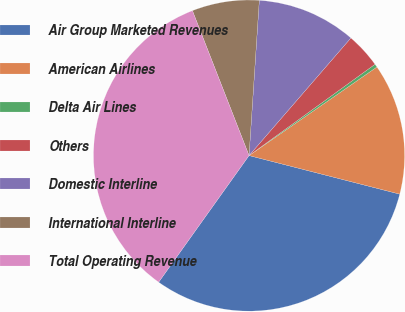Convert chart. <chart><loc_0><loc_0><loc_500><loc_500><pie_chart><fcel>Air Group Marketed Revenues<fcel>American Airlines<fcel>Delta Air Lines<fcel>Others<fcel>Domestic Interline<fcel>International Interline<fcel>Total Operating Revenue<nl><fcel>30.88%<fcel>13.63%<fcel>0.34%<fcel>3.66%<fcel>10.31%<fcel>6.98%<fcel>34.21%<nl></chart> 